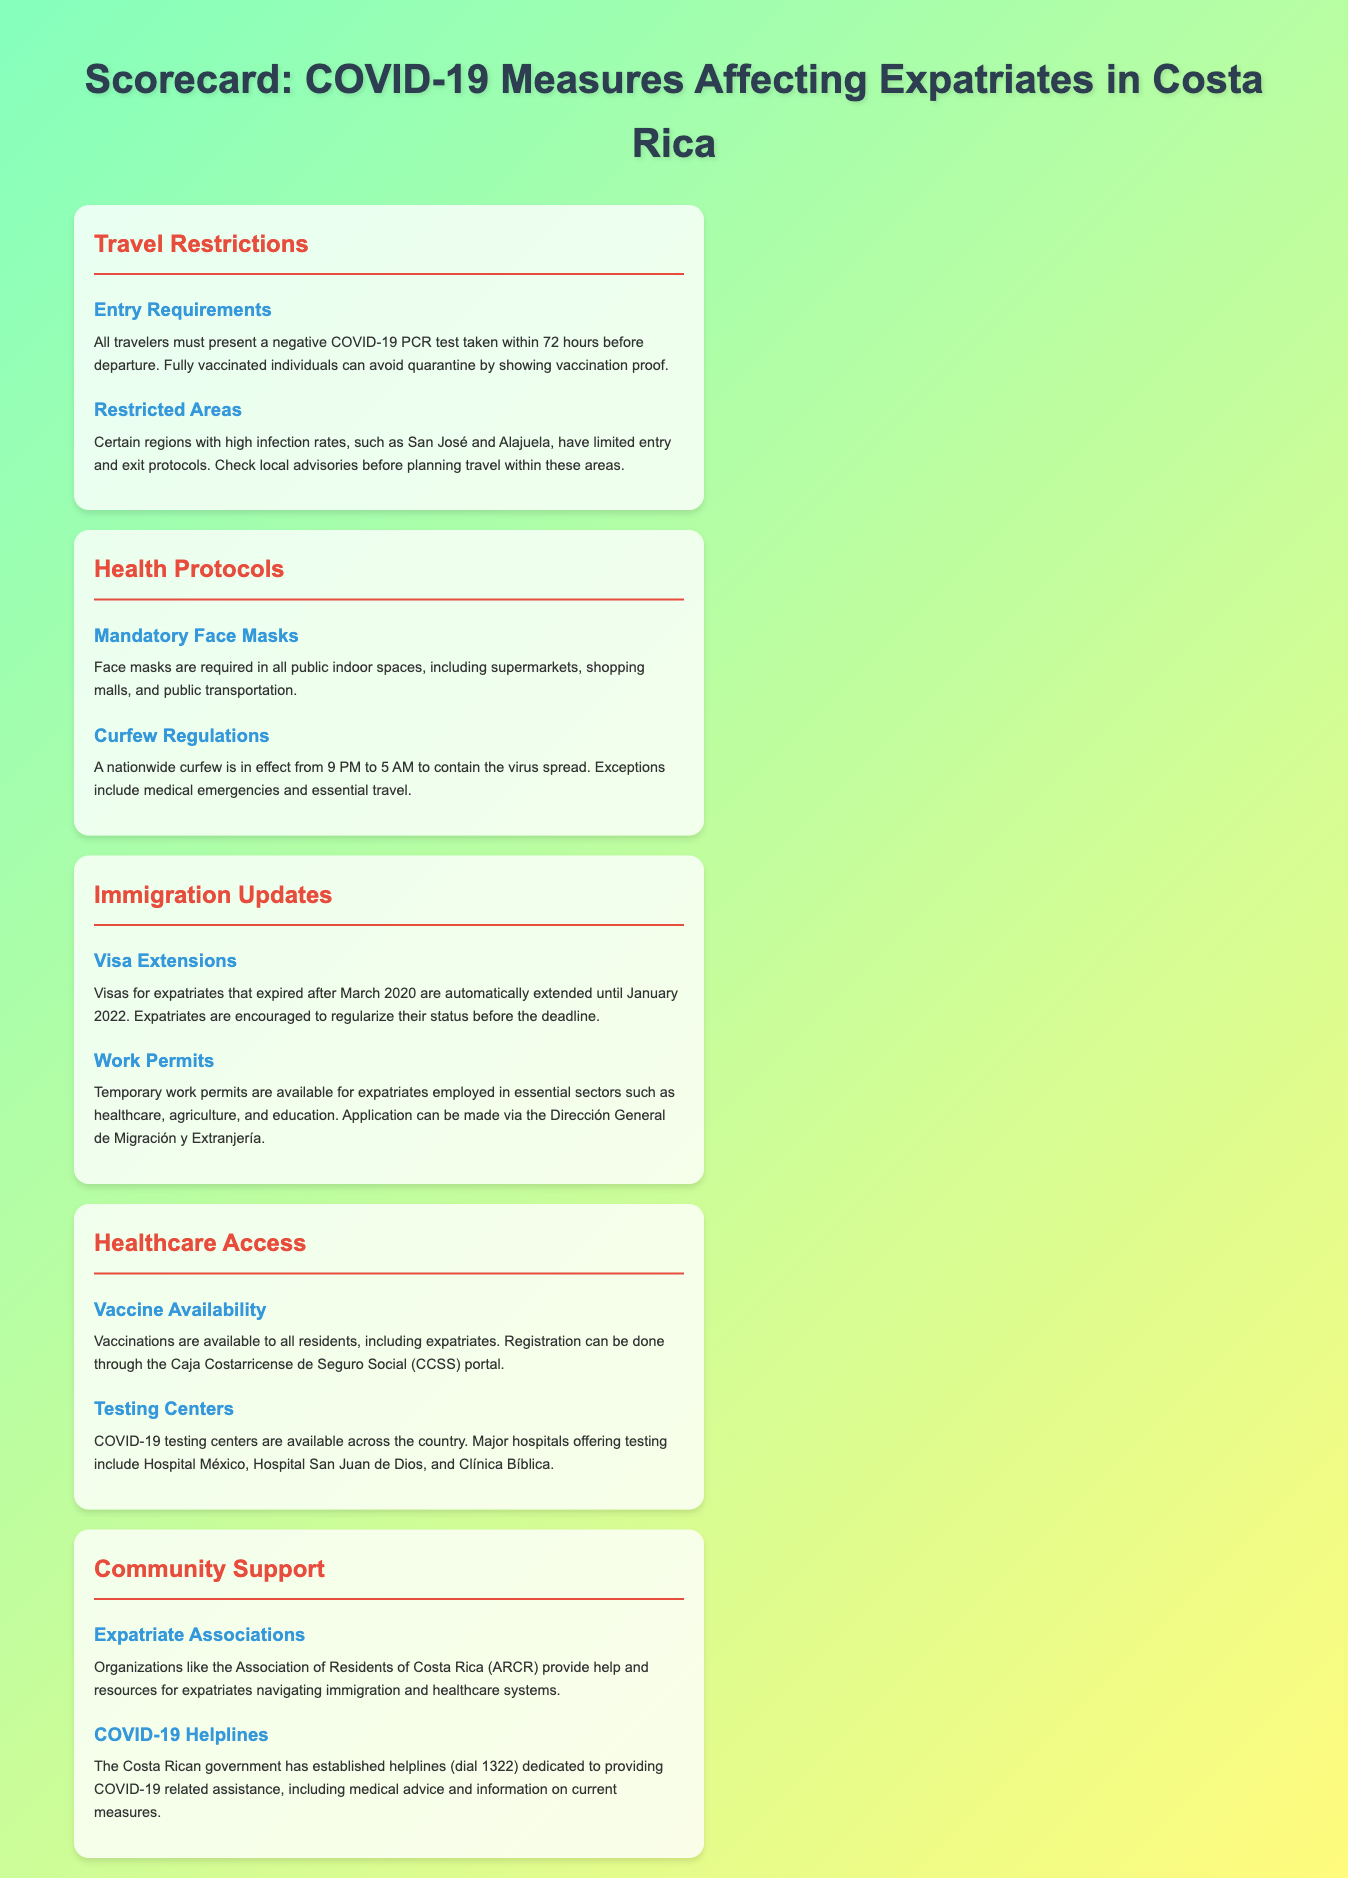What is required for entry into Costa Rica? Travelers must present a negative COVID-19 PCR test taken within 72 hours before departure.
Answer: Negative COVID-19 PCR test What are the curfew hours in Costa Rica? A nationwide curfew is in effect to contain the virus spread from 9 PM to 5 AM.
Answer: 9 PM to 5 AM What is the deadline for expatriates to regularize their status? Visas expired after March 2020 are extended until January 2022.
Answer: January 2022 Where can expatriates get vaccinated in Costa Rica? Vaccinations are available to all residents through the Caja Costarricense de Seguro Social (CCSS) portal.
Answer: CCSS portal What assistance do organizations like ARCR offer? The Association of Residents of Costa Rica provides help and resources for expatriates navigating immigration and healthcare systems.
Answer: Help and resources What exceptions exist for the nationwide curfew? Exceptions include medical emergencies and essential travel.
Answer: Medical emergencies and essential travel How can expatriates apply for temporary work permits? Application can be made via the Dirección General de Migración y Extranjería.
Answer: Dirección General de Migración y Extranjería Which major hospitals offer COVID-19 testing? Major hospitals include Hospital México, Hospital San Juan de Dios, and Clínica Bíblica.
Answer: Hospital México, Hospital San Juan de Dios, and Clínica Bíblica 